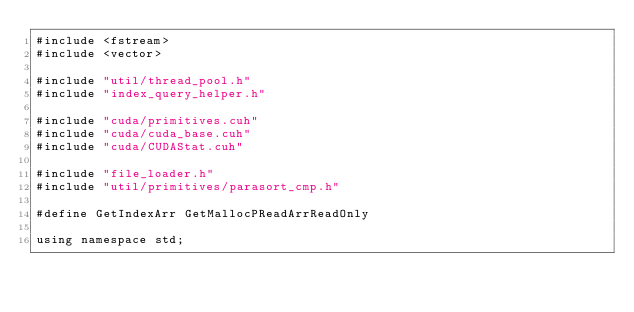<code> <loc_0><loc_0><loc_500><loc_500><_Cuda_>#include <fstream>
#include <vector>

#include "util/thread_pool.h"
#include "index_query_helper.h"

#include "cuda/primitives.cuh"
#include "cuda/cuda_base.cuh"
#include "cuda/CUDAStat.cuh"

#include "file_loader.h"
#include "util/primitives/parasort_cmp.h"

#define GetIndexArr GetMallocPReadArrReadOnly

using namespace std;
</code> 